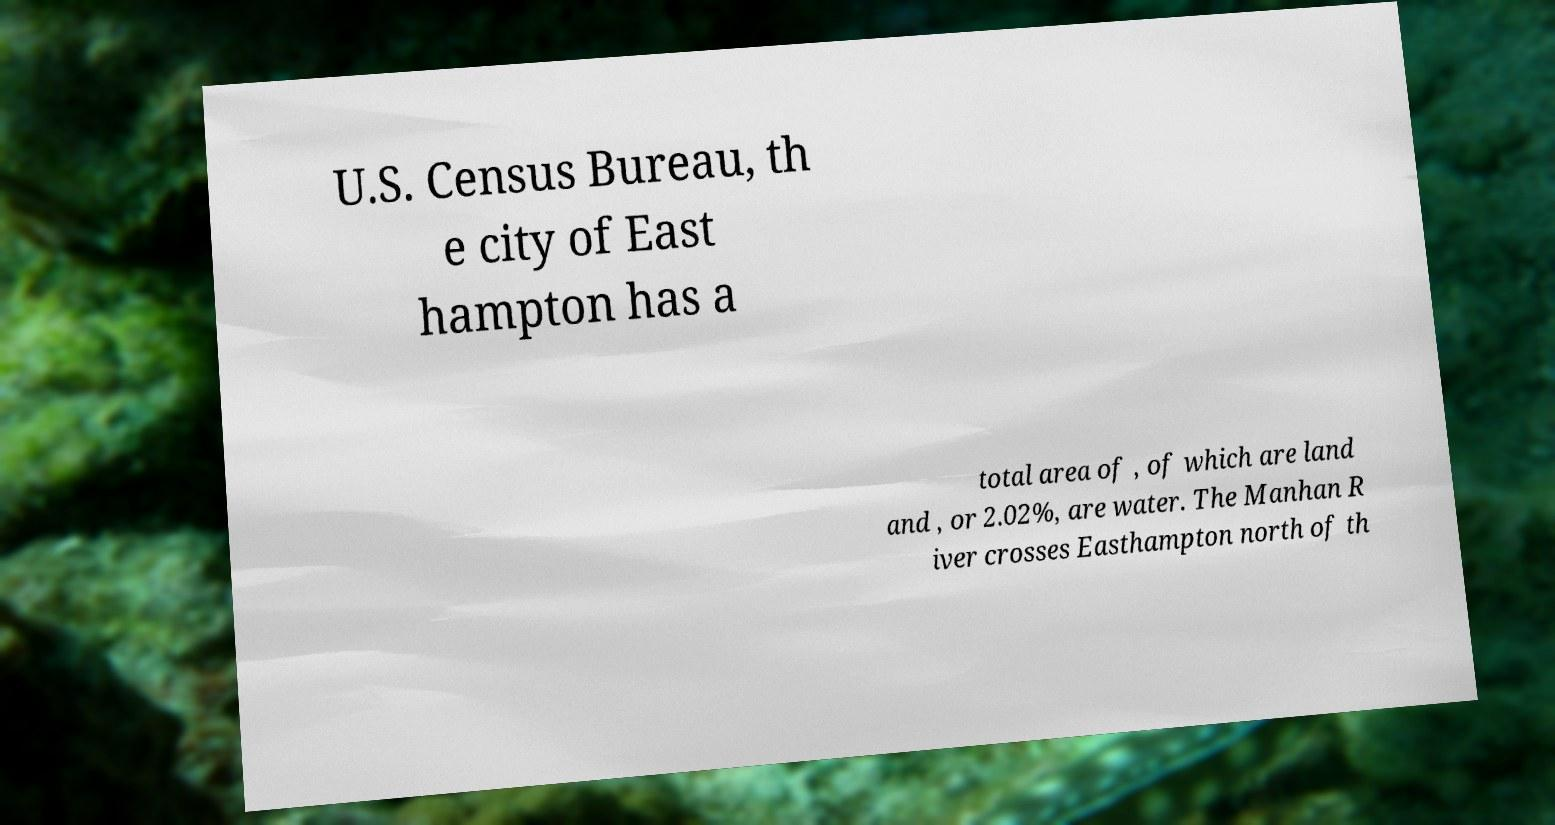Please read and relay the text visible in this image. What does it say? U.S. Census Bureau, th e city of East hampton has a total area of , of which are land and , or 2.02%, are water. The Manhan R iver crosses Easthampton north of th 